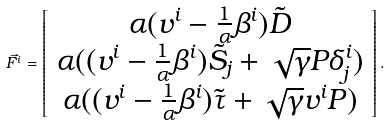Convert formula to latex. <formula><loc_0><loc_0><loc_500><loc_500>\vec { F ^ { i } } = \left [ \begin{array} { c } \alpha ( v ^ { i } - \frac { 1 } { \alpha } { \beta } ^ { i } ) \tilde { D } \\ \alpha ( ( v ^ { i } - \frac { 1 } { \alpha } { \beta } ^ { i } ) \tilde { S _ { j } } + \sqrt { \gamma } P { \delta } ^ { i } _ { j } ) \\ \alpha ( ( v ^ { i } - \frac { 1 } { \alpha } { \beta } ^ { i } ) \tilde { \tau } + \sqrt { \gamma } v ^ { i } P ) \end{array} \right ] .</formula> 